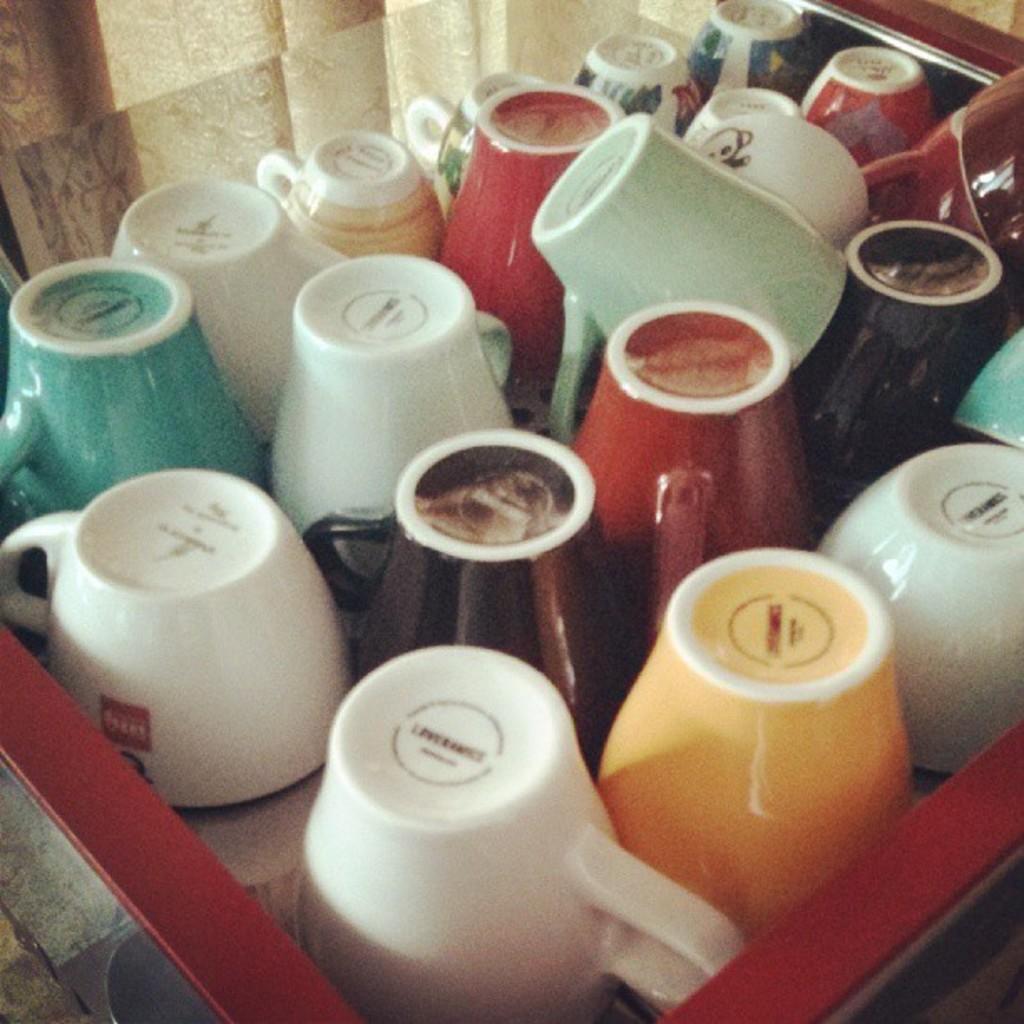How would you summarize this image in a sentence or two? In this picture we can see colorful cups on the platform and we can see glass and curtain. 